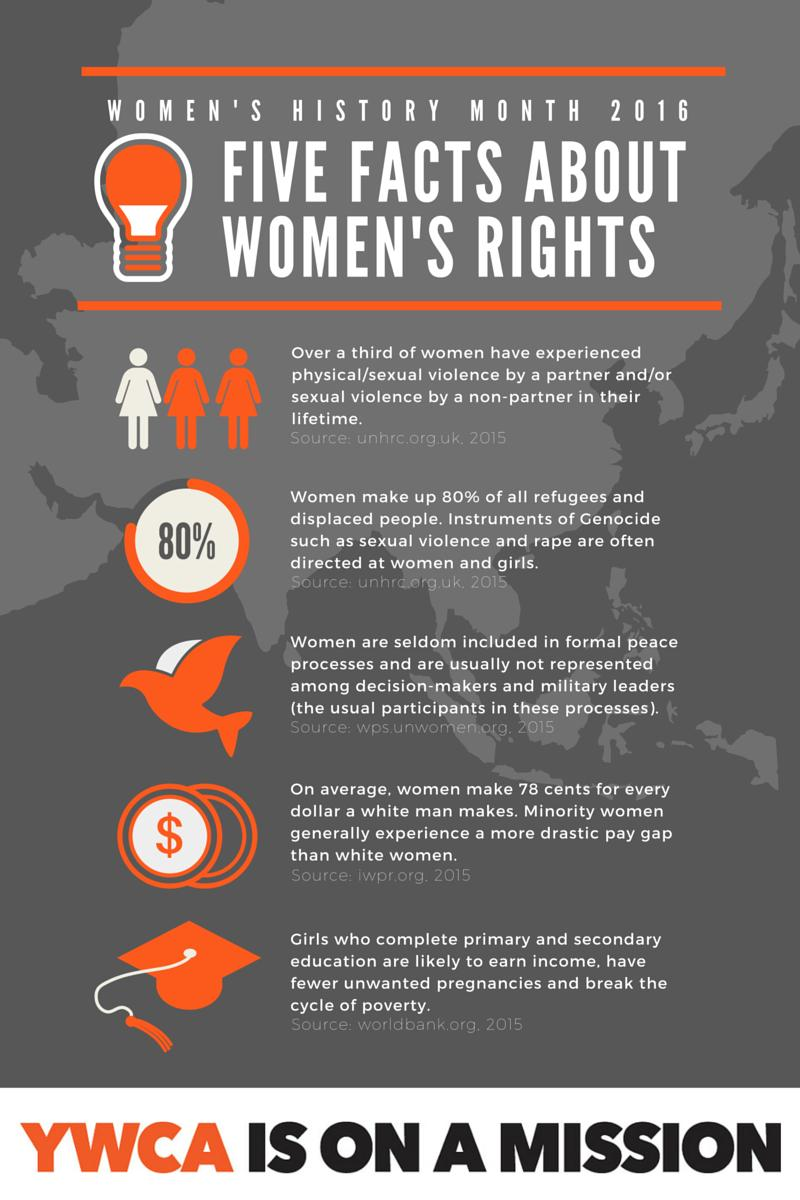Identify some key points in this picture. According to data, only 20% of refugees and displaced people are not women. White women are paid less than minority women. The image shows a currency symbol that is the dollar symbol. Uneducated girls are more susceptible to unwanted pregnancies and poverty than educated girls, according to research. Men are disproportionately represented in peace processes and decision-making processes, reflecting a persistent gender imbalance that perpetuates gender inequality and undermines the full participation and agency of women in peacebuilding efforts. 